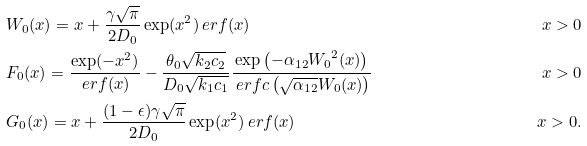Convert formula to latex. <formula><loc_0><loc_0><loc_500><loc_500>& W _ { 0 } ( x ) = x + \frac { \gamma \sqrt { \pi } } { 2 D _ { 0 } } \exp ( x ^ { 2 } ) \ e r f ( x ) & x > 0 \\ & F _ { 0 } ( x ) = \frac { \exp ( - x ^ { 2 } ) } { \ e r f ( x ) } - \frac { \theta _ { 0 } \sqrt { k _ { 2 } c _ { 2 } } } { D _ { 0 } \sqrt { k _ { 1 } c _ { 1 } } } \frac { \exp \left ( - \alpha _ { 1 2 } { W _ { 0 } } ^ { 2 } ( x ) \right ) } { \ e r f c \left ( \sqrt { \alpha _ { 1 2 } } W _ { 0 } ( x ) \right ) } & x > 0 \\ & G _ { 0 } ( x ) = x + \frac { ( 1 - \epsilon ) \gamma \sqrt { \pi } } { 2 D _ { 0 } } \exp ( x ^ { 2 } ) \ e r f ( x ) & x > 0 .</formula> 